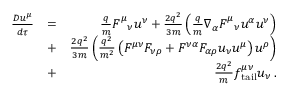Convert formula to latex. <formula><loc_0><loc_0><loc_500><loc_500>\begin{array} { r l r } { \frac { D u ^ { \mu } } { d \tau } } & { = } & { \frac { q } { m } F _ { \quad n u } ^ { \mu } u ^ { \nu } + \frac { 2 q ^ { 2 } } { 3 m } \left ( \frac { q } { m } \nabla _ { \alpha } F _ { \quad n u } ^ { \mu } u ^ { \alpha } u ^ { \nu } \right ) } \\ & { + } & { \frac { 2 q ^ { 2 } } { 3 m } \left ( \frac { q ^ { 2 } } { m ^ { 2 } } \left ( F ^ { \mu \nu } F _ { \nu \rho } + F ^ { \nu \alpha } F _ { \alpha \rho } u _ { \nu } u ^ { \mu } \right ) u ^ { \rho } \right ) } \\ & { + } & { \frac { 2 q ^ { 2 } } { m } f _ { t a i l } ^ { \mu \nu } u _ { \nu } \, . } \end{array}</formula> 